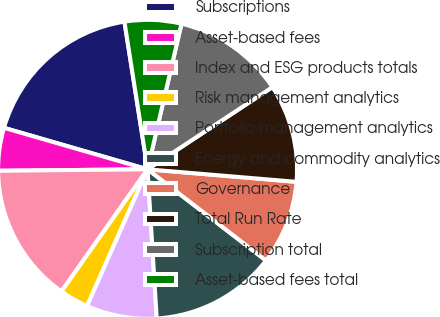Convert chart to OTSL. <chart><loc_0><loc_0><loc_500><loc_500><pie_chart><fcel>Subscriptions<fcel>Asset-based fees<fcel>Index and ESG products totals<fcel>Risk management analytics<fcel>Portfolio management analytics<fcel>Energy and commodity analytics<fcel>Governance<fcel>Total Run Rate<fcel>Subscription total<fcel>Asset-based fees total<nl><fcel>18.05%<fcel>4.63%<fcel>15.07%<fcel>3.14%<fcel>7.61%<fcel>13.58%<fcel>9.11%<fcel>10.6%<fcel>12.09%<fcel>6.12%<nl></chart> 